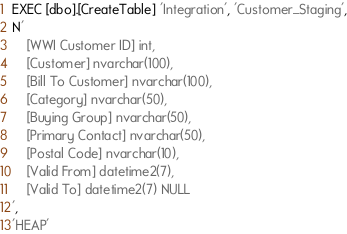Convert code to text. <code><loc_0><loc_0><loc_500><loc_500><_SQL_>EXEC [dbo].[CreateTable] 'Integration', 'Customer_Staging',
N'
    [WWI Customer ID] int,
    [Customer] nvarchar(100),
    [Bill To Customer] nvarchar(100),
    [Category] nvarchar(50),
    [Buying Group] nvarchar(50),
    [Primary Contact] nvarchar(50),
    [Postal Code] nvarchar(10),
    [Valid From] datetime2(7),
    [Valid To] datetime2(7) NULL
',
'HEAP'</code> 